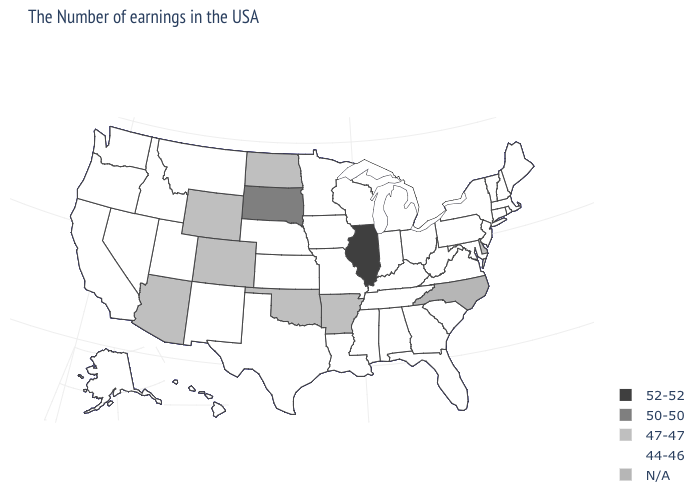What is the value of North Dakota?
Keep it brief. 47-47. What is the value of New Hampshire?
Write a very short answer. 44-46. What is the highest value in states that border New Hampshire?
Concise answer only. 44-46. Name the states that have a value in the range 50-50?
Short answer required. South Dakota. Among the states that border Ohio , which have the lowest value?
Give a very brief answer. Pennsylvania, West Virginia, Michigan, Kentucky, Indiana. Name the states that have a value in the range 47-47?
Give a very brief answer. Delaware, Arkansas, Oklahoma, North Dakota, Wyoming, Colorado, Arizona. What is the value of Colorado?
Write a very short answer. 47-47. Does the first symbol in the legend represent the smallest category?
Short answer required. No. What is the value of Missouri?
Concise answer only. 44-46. Does Missouri have the lowest value in the MidWest?
Quick response, please. Yes. Among the states that border Missouri , does Illinois have the lowest value?
Keep it brief. No. Which states have the lowest value in the Northeast?
Concise answer only. Maine, Massachusetts, Rhode Island, New Hampshire, Vermont, Connecticut, New York, New Jersey, Pennsylvania. Which states have the highest value in the USA?
Answer briefly. Illinois. Does Oregon have the highest value in the West?
Concise answer only. No. 